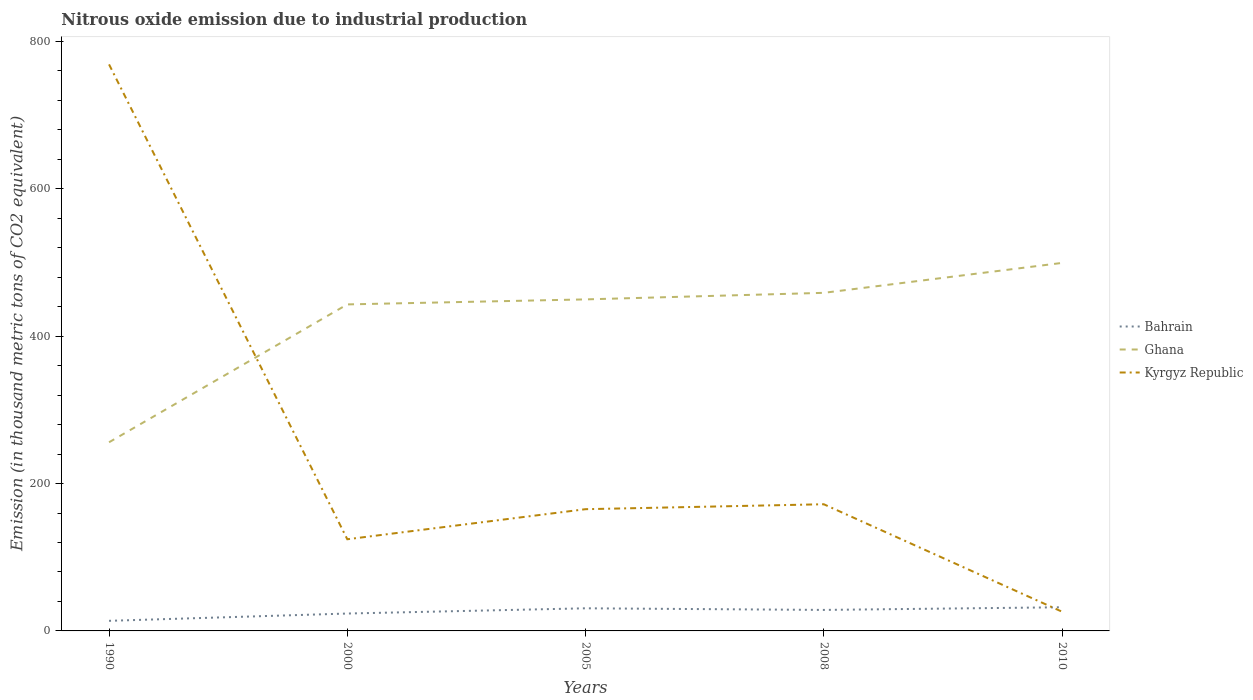How many different coloured lines are there?
Ensure brevity in your answer.  3. Across all years, what is the maximum amount of nitrous oxide emitted in Kyrgyz Republic?
Your answer should be very brief. 26.1. In which year was the amount of nitrous oxide emitted in Bahrain maximum?
Your answer should be compact. 1990. What is the total amount of nitrous oxide emitted in Kyrgyz Republic in the graph?
Your response must be concise. 742.7. What is the difference between the highest and the second highest amount of nitrous oxide emitted in Ghana?
Give a very brief answer. 243.4. How many lines are there?
Ensure brevity in your answer.  3. What is the difference between two consecutive major ticks on the Y-axis?
Your response must be concise. 200. Are the values on the major ticks of Y-axis written in scientific E-notation?
Give a very brief answer. No. Does the graph contain any zero values?
Your response must be concise. No. What is the title of the graph?
Ensure brevity in your answer.  Nitrous oxide emission due to industrial production. What is the label or title of the X-axis?
Make the answer very short. Years. What is the label or title of the Y-axis?
Make the answer very short. Emission (in thousand metric tons of CO2 equivalent). What is the Emission (in thousand metric tons of CO2 equivalent) of Ghana in 1990?
Provide a succinct answer. 256. What is the Emission (in thousand metric tons of CO2 equivalent) of Kyrgyz Republic in 1990?
Your answer should be very brief. 768.8. What is the Emission (in thousand metric tons of CO2 equivalent) of Bahrain in 2000?
Provide a short and direct response. 23.6. What is the Emission (in thousand metric tons of CO2 equivalent) of Ghana in 2000?
Ensure brevity in your answer.  443.1. What is the Emission (in thousand metric tons of CO2 equivalent) of Kyrgyz Republic in 2000?
Ensure brevity in your answer.  124.4. What is the Emission (in thousand metric tons of CO2 equivalent) of Bahrain in 2005?
Your answer should be very brief. 30.7. What is the Emission (in thousand metric tons of CO2 equivalent) in Ghana in 2005?
Offer a terse response. 449.9. What is the Emission (in thousand metric tons of CO2 equivalent) in Kyrgyz Republic in 2005?
Your response must be concise. 165.2. What is the Emission (in thousand metric tons of CO2 equivalent) of Ghana in 2008?
Make the answer very short. 458.8. What is the Emission (in thousand metric tons of CO2 equivalent) in Kyrgyz Republic in 2008?
Offer a very short reply. 171.9. What is the Emission (in thousand metric tons of CO2 equivalent) in Bahrain in 2010?
Give a very brief answer. 32.1. What is the Emission (in thousand metric tons of CO2 equivalent) in Ghana in 2010?
Provide a succinct answer. 499.4. What is the Emission (in thousand metric tons of CO2 equivalent) of Kyrgyz Republic in 2010?
Ensure brevity in your answer.  26.1. Across all years, what is the maximum Emission (in thousand metric tons of CO2 equivalent) in Bahrain?
Your answer should be compact. 32.1. Across all years, what is the maximum Emission (in thousand metric tons of CO2 equivalent) in Ghana?
Offer a terse response. 499.4. Across all years, what is the maximum Emission (in thousand metric tons of CO2 equivalent) in Kyrgyz Republic?
Your answer should be very brief. 768.8. Across all years, what is the minimum Emission (in thousand metric tons of CO2 equivalent) in Bahrain?
Your response must be concise. 13.7. Across all years, what is the minimum Emission (in thousand metric tons of CO2 equivalent) of Ghana?
Your answer should be compact. 256. Across all years, what is the minimum Emission (in thousand metric tons of CO2 equivalent) of Kyrgyz Republic?
Keep it short and to the point. 26.1. What is the total Emission (in thousand metric tons of CO2 equivalent) of Bahrain in the graph?
Give a very brief answer. 128.6. What is the total Emission (in thousand metric tons of CO2 equivalent) in Ghana in the graph?
Your answer should be very brief. 2107.2. What is the total Emission (in thousand metric tons of CO2 equivalent) of Kyrgyz Republic in the graph?
Provide a short and direct response. 1256.4. What is the difference between the Emission (in thousand metric tons of CO2 equivalent) in Bahrain in 1990 and that in 2000?
Make the answer very short. -9.9. What is the difference between the Emission (in thousand metric tons of CO2 equivalent) in Ghana in 1990 and that in 2000?
Your answer should be compact. -187.1. What is the difference between the Emission (in thousand metric tons of CO2 equivalent) of Kyrgyz Republic in 1990 and that in 2000?
Your answer should be compact. 644.4. What is the difference between the Emission (in thousand metric tons of CO2 equivalent) of Ghana in 1990 and that in 2005?
Your response must be concise. -193.9. What is the difference between the Emission (in thousand metric tons of CO2 equivalent) of Kyrgyz Republic in 1990 and that in 2005?
Offer a very short reply. 603.6. What is the difference between the Emission (in thousand metric tons of CO2 equivalent) of Bahrain in 1990 and that in 2008?
Make the answer very short. -14.8. What is the difference between the Emission (in thousand metric tons of CO2 equivalent) in Ghana in 1990 and that in 2008?
Your answer should be compact. -202.8. What is the difference between the Emission (in thousand metric tons of CO2 equivalent) of Kyrgyz Republic in 1990 and that in 2008?
Keep it short and to the point. 596.9. What is the difference between the Emission (in thousand metric tons of CO2 equivalent) of Bahrain in 1990 and that in 2010?
Your response must be concise. -18.4. What is the difference between the Emission (in thousand metric tons of CO2 equivalent) of Ghana in 1990 and that in 2010?
Keep it short and to the point. -243.4. What is the difference between the Emission (in thousand metric tons of CO2 equivalent) of Kyrgyz Republic in 1990 and that in 2010?
Make the answer very short. 742.7. What is the difference between the Emission (in thousand metric tons of CO2 equivalent) of Bahrain in 2000 and that in 2005?
Your answer should be very brief. -7.1. What is the difference between the Emission (in thousand metric tons of CO2 equivalent) in Ghana in 2000 and that in 2005?
Ensure brevity in your answer.  -6.8. What is the difference between the Emission (in thousand metric tons of CO2 equivalent) in Kyrgyz Republic in 2000 and that in 2005?
Offer a very short reply. -40.8. What is the difference between the Emission (in thousand metric tons of CO2 equivalent) of Bahrain in 2000 and that in 2008?
Give a very brief answer. -4.9. What is the difference between the Emission (in thousand metric tons of CO2 equivalent) in Ghana in 2000 and that in 2008?
Offer a very short reply. -15.7. What is the difference between the Emission (in thousand metric tons of CO2 equivalent) of Kyrgyz Republic in 2000 and that in 2008?
Offer a very short reply. -47.5. What is the difference between the Emission (in thousand metric tons of CO2 equivalent) in Bahrain in 2000 and that in 2010?
Offer a very short reply. -8.5. What is the difference between the Emission (in thousand metric tons of CO2 equivalent) in Ghana in 2000 and that in 2010?
Provide a short and direct response. -56.3. What is the difference between the Emission (in thousand metric tons of CO2 equivalent) of Kyrgyz Republic in 2000 and that in 2010?
Keep it short and to the point. 98.3. What is the difference between the Emission (in thousand metric tons of CO2 equivalent) of Bahrain in 2005 and that in 2008?
Ensure brevity in your answer.  2.2. What is the difference between the Emission (in thousand metric tons of CO2 equivalent) in Ghana in 2005 and that in 2008?
Make the answer very short. -8.9. What is the difference between the Emission (in thousand metric tons of CO2 equivalent) in Bahrain in 2005 and that in 2010?
Your response must be concise. -1.4. What is the difference between the Emission (in thousand metric tons of CO2 equivalent) in Ghana in 2005 and that in 2010?
Your response must be concise. -49.5. What is the difference between the Emission (in thousand metric tons of CO2 equivalent) of Kyrgyz Republic in 2005 and that in 2010?
Your answer should be compact. 139.1. What is the difference between the Emission (in thousand metric tons of CO2 equivalent) in Bahrain in 2008 and that in 2010?
Offer a very short reply. -3.6. What is the difference between the Emission (in thousand metric tons of CO2 equivalent) of Ghana in 2008 and that in 2010?
Your answer should be compact. -40.6. What is the difference between the Emission (in thousand metric tons of CO2 equivalent) of Kyrgyz Republic in 2008 and that in 2010?
Your answer should be very brief. 145.8. What is the difference between the Emission (in thousand metric tons of CO2 equivalent) in Bahrain in 1990 and the Emission (in thousand metric tons of CO2 equivalent) in Ghana in 2000?
Your answer should be very brief. -429.4. What is the difference between the Emission (in thousand metric tons of CO2 equivalent) in Bahrain in 1990 and the Emission (in thousand metric tons of CO2 equivalent) in Kyrgyz Republic in 2000?
Provide a short and direct response. -110.7. What is the difference between the Emission (in thousand metric tons of CO2 equivalent) in Ghana in 1990 and the Emission (in thousand metric tons of CO2 equivalent) in Kyrgyz Republic in 2000?
Your answer should be very brief. 131.6. What is the difference between the Emission (in thousand metric tons of CO2 equivalent) in Bahrain in 1990 and the Emission (in thousand metric tons of CO2 equivalent) in Ghana in 2005?
Your answer should be very brief. -436.2. What is the difference between the Emission (in thousand metric tons of CO2 equivalent) of Bahrain in 1990 and the Emission (in thousand metric tons of CO2 equivalent) of Kyrgyz Republic in 2005?
Your answer should be compact. -151.5. What is the difference between the Emission (in thousand metric tons of CO2 equivalent) of Ghana in 1990 and the Emission (in thousand metric tons of CO2 equivalent) of Kyrgyz Republic in 2005?
Provide a short and direct response. 90.8. What is the difference between the Emission (in thousand metric tons of CO2 equivalent) in Bahrain in 1990 and the Emission (in thousand metric tons of CO2 equivalent) in Ghana in 2008?
Provide a short and direct response. -445.1. What is the difference between the Emission (in thousand metric tons of CO2 equivalent) in Bahrain in 1990 and the Emission (in thousand metric tons of CO2 equivalent) in Kyrgyz Republic in 2008?
Give a very brief answer. -158.2. What is the difference between the Emission (in thousand metric tons of CO2 equivalent) of Ghana in 1990 and the Emission (in thousand metric tons of CO2 equivalent) of Kyrgyz Republic in 2008?
Your answer should be very brief. 84.1. What is the difference between the Emission (in thousand metric tons of CO2 equivalent) of Bahrain in 1990 and the Emission (in thousand metric tons of CO2 equivalent) of Ghana in 2010?
Offer a terse response. -485.7. What is the difference between the Emission (in thousand metric tons of CO2 equivalent) in Ghana in 1990 and the Emission (in thousand metric tons of CO2 equivalent) in Kyrgyz Republic in 2010?
Your answer should be very brief. 229.9. What is the difference between the Emission (in thousand metric tons of CO2 equivalent) of Bahrain in 2000 and the Emission (in thousand metric tons of CO2 equivalent) of Ghana in 2005?
Provide a succinct answer. -426.3. What is the difference between the Emission (in thousand metric tons of CO2 equivalent) in Bahrain in 2000 and the Emission (in thousand metric tons of CO2 equivalent) in Kyrgyz Republic in 2005?
Ensure brevity in your answer.  -141.6. What is the difference between the Emission (in thousand metric tons of CO2 equivalent) in Ghana in 2000 and the Emission (in thousand metric tons of CO2 equivalent) in Kyrgyz Republic in 2005?
Ensure brevity in your answer.  277.9. What is the difference between the Emission (in thousand metric tons of CO2 equivalent) of Bahrain in 2000 and the Emission (in thousand metric tons of CO2 equivalent) of Ghana in 2008?
Offer a very short reply. -435.2. What is the difference between the Emission (in thousand metric tons of CO2 equivalent) of Bahrain in 2000 and the Emission (in thousand metric tons of CO2 equivalent) of Kyrgyz Republic in 2008?
Keep it short and to the point. -148.3. What is the difference between the Emission (in thousand metric tons of CO2 equivalent) of Ghana in 2000 and the Emission (in thousand metric tons of CO2 equivalent) of Kyrgyz Republic in 2008?
Your response must be concise. 271.2. What is the difference between the Emission (in thousand metric tons of CO2 equivalent) of Bahrain in 2000 and the Emission (in thousand metric tons of CO2 equivalent) of Ghana in 2010?
Give a very brief answer. -475.8. What is the difference between the Emission (in thousand metric tons of CO2 equivalent) in Ghana in 2000 and the Emission (in thousand metric tons of CO2 equivalent) in Kyrgyz Republic in 2010?
Keep it short and to the point. 417. What is the difference between the Emission (in thousand metric tons of CO2 equivalent) in Bahrain in 2005 and the Emission (in thousand metric tons of CO2 equivalent) in Ghana in 2008?
Make the answer very short. -428.1. What is the difference between the Emission (in thousand metric tons of CO2 equivalent) in Bahrain in 2005 and the Emission (in thousand metric tons of CO2 equivalent) in Kyrgyz Republic in 2008?
Your response must be concise. -141.2. What is the difference between the Emission (in thousand metric tons of CO2 equivalent) of Ghana in 2005 and the Emission (in thousand metric tons of CO2 equivalent) of Kyrgyz Republic in 2008?
Your answer should be very brief. 278. What is the difference between the Emission (in thousand metric tons of CO2 equivalent) of Bahrain in 2005 and the Emission (in thousand metric tons of CO2 equivalent) of Ghana in 2010?
Offer a very short reply. -468.7. What is the difference between the Emission (in thousand metric tons of CO2 equivalent) in Bahrain in 2005 and the Emission (in thousand metric tons of CO2 equivalent) in Kyrgyz Republic in 2010?
Offer a very short reply. 4.6. What is the difference between the Emission (in thousand metric tons of CO2 equivalent) in Ghana in 2005 and the Emission (in thousand metric tons of CO2 equivalent) in Kyrgyz Republic in 2010?
Your answer should be compact. 423.8. What is the difference between the Emission (in thousand metric tons of CO2 equivalent) of Bahrain in 2008 and the Emission (in thousand metric tons of CO2 equivalent) of Ghana in 2010?
Ensure brevity in your answer.  -470.9. What is the difference between the Emission (in thousand metric tons of CO2 equivalent) of Bahrain in 2008 and the Emission (in thousand metric tons of CO2 equivalent) of Kyrgyz Republic in 2010?
Ensure brevity in your answer.  2.4. What is the difference between the Emission (in thousand metric tons of CO2 equivalent) in Ghana in 2008 and the Emission (in thousand metric tons of CO2 equivalent) in Kyrgyz Republic in 2010?
Your response must be concise. 432.7. What is the average Emission (in thousand metric tons of CO2 equivalent) of Bahrain per year?
Provide a succinct answer. 25.72. What is the average Emission (in thousand metric tons of CO2 equivalent) in Ghana per year?
Give a very brief answer. 421.44. What is the average Emission (in thousand metric tons of CO2 equivalent) of Kyrgyz Republic per year?
Your answer should be very brief. 251.28. In the year 1990, what is the difference between the Emission (in thousand metric tons of CO2 equivalent) in Bahrain and Emission (in thousand metric tons of CO2 equivalent) in Ghana?
Make the answer very short. -242.3. In the year 1990, what is the difference between the Emission (in thousand metric tons of CO2 equivalent) of Bahrain and Emission (in thousand metric tons of CO2 equivalent) of Kyrgyz Republic?
Your response must be concise. -755.1. In the year 1990, what is the difference between the Emission (in thousand metric tons of CO2 equivalent) in Ghana and Emission (in thousand metric tons of CO2 equivalent) in Kyrgyz Republic?
Provide a succinct answer. -512.8. In the year 2000, what is the difference between the Emission (in thousand metric tons of CO2 equivalent) in Bahrain and Emission (in thousand metric tons of CO2 equivalent) in Ghana?
Your response must be concise. -419.5. In the year 2000, what is the difference between the Emission (in thousand metric tons of CO2 equivalent) in Bahrain and Emission (in thousand metric tons of CO2 equivalent) in Kyrgyz Republic?
Give a very brief answer. -100.8. In the year 2000, what is the difference between the Emission (in thousand metric tons of CO2 equivalent) of Ghana and Emission (in thousand metric tons of CO2 equivalent) of Kyrgyz Republic?
Keep it short and to the point. 318.7. In the year 2005, what is the difference between the Emission (in thousand metric tons of CO2 equivalent) in Bahrain and Emission (in thousand metric tons of CO2 equivalent) in Ghana?
Provide a succinct answer. -419.2. In the year 2005, what is the difference between the Emission (in thousand metric tons of CO2 equivalent) in Bahrain and Emission (in thousand metric tons of CO2 equivalent) in Kyrgyz Republic?
Your answer should be compact. -134.5. In the year 2005, what is the difference between the Emission (in thousand metric tons of CO2 equivalent) in Ghana and Emission (in thousand metric tons of CO2 equivalent) in Kyrgyz Republic?
Make the answer very short. 284.7. In the year 2008, what is the difference between the Emission (in thousand metric tons of CO2 equivalent) of Bahrain and Emission (in thousand metric tons of CO2 equivalent) of Ghana?
Offer a terse response. -430.3. In the year 2008, what is the difference between the Emission (in thousand metric tons of CO2 equivalent) of Bahrain and Emission (in thousand metric tons of CO2 equivalent) of Kyrgyz Republic?
Your answer should be compact. -143.4. In the year 2008, what is the difference between the Emission (in thousand metric tons of CO2 equivalent) of Ghana and Emission (in thousand metric tons of CO2 equivalent) of Kyrgyz Republic?
Make the answer very short. 286.9. In the year 2010, what is the difference between the Emission (in thousand metric tons of CO2 equivalent) in Bahrain and Emission (in thousand metric tons of CO2 equivalent) in Ghana?
Your answer should be compact. -467.3. In the year 2010, what is the difference between the Emission (in thousand metric tons of CO2 equivalent) of Bahrain and Emission (in thousand metric tons of CO2 equivalent) of Kyrgyz Republic?
Your answer should be very brief. 6. In the year 2010, what is the difference between the Emission (in thousand metric tons of CO2 equivalent) in Ghana and Emission (in thousand metric tons of CO2 equivalent) in Kyrgyz Republic?
Make the answer very short. 473.3. What is the ratio of the Emission (in thousand metric tons of CO2 equivalent) in Bahrain in 1990 to that in 2000?
Ensure brevity in your answer.  0.58. What is the ratio of the Emission (in thousand metric tons of CO2 equivalent) in Ghana in 1990 to that in 2000?
Keep it short and to the point. 0.58. What is the ratio of the Emission (in thousand metric tons of CO2 equivalent) of Kyrgyz Republic in 1990 to that in 2000?
Keep it short and to the point. 6.18. What is the ratio of the Emission (in thousand metric tons of CO2 equivalent) in Bahrain in 1990 to that in 2005?
Offer a very short reply. 0.45. What is the ratio of the Emission (in thousand metric tons of CO2 equivalent) in Ghana in 1990 to that in 2005?
Offer a terse response. 0.57. What is the ratio of the Emission (in thousand metric tons of CO2 equivalent) of Kyrgyz Republic in 1990 to that in 2005?
Offer a very short reply. 4.65. What is the ratio of the Emission (in thousand metric tons of CO2 equivalent) of Bahrain in 1990 to that in 2008?
Your response must be concise. 0.48. What is the ratio of the Emission (in thousand metric tons of CO2 equivalent) of Ghana in 1990 to that in 2008?
Keep it short and to the point. 0.56. What is the ratio of the Emission (in thousand metric tons of CO2 equivalent) of Kyrgyz Republic in 1990 to that in 2008?
Provide a short and direct response. 4.47. What is the ratio of the Emission (in thousand metric tons of CO2 equivalent) in Bahrain in 1990 to that in 2010?
Offer a terse response. 0.43. What is the ratio of the Emission (in thousand metric tons of CO2 equivalent) in Ghana in 1990 to that in 2010?
Provide a succinct answer. 0.51. What is the ratio of the Emission (in thousand metric tons of CO2 equivalent) of Kyrgyz Republic in 1990 to that in 2010?
Provide a succinct answer. 29.46. What is the ratio of the Emission (in thousand metric tons of CO2 equivalent) of Bahrain in 2000 to that in 2005?
Make the answer very short. 0.77. What is the ratio of the Emission (in thousand metric tons of CO2 equivalent) in Ghana in 2000 to that in 2005?
Keep it short and to the point. 0.98. What is the ratio of the Emission (in thousand metric tons of CO2 equivalent) in Kyrgyz Republic in 2000 to that in 2005?
Provide a succinct answer. 0.75. What is the ratio of the Emission (in thousand metric tons of CO2 equivalent) of Bahrain in 2000 to that in 2008?
Your answer should be compact. 0.83. What is the ratio of the Emission (in thousand metric tons of CO2 equivalent) in Ghana in 2000 to that in 2008?
Your answer should be very brief. 0.97. What is the ratio of the Emission (in thousand metric tons of CO2 equivalent) of Kyrgyz Republic in 2000 to that in 2008?
Give a very brief answer. 0.72. What is the ratio of the Emission (in thousand metric tons of CO2 equivalent) of Bahrain in 2000 to that in 2010?
Offer a terse response. 0.74. What is the ratio of the Emission (in thousand metric tons of CO2 equivalent) of Ghana in 2000 to that in 2010?
Provide a succinct answer. 0.89. What is the ratio of the Emission (in thousand metric tons of CO2 equivalent) in Kyrgyz Republic in 2000 to that in 2010?
Make the answer very short. 4.77. What is the ratio of the Emission (in thousand metric tons of CO2 equivalent) of Bahrain in 2005 to that in 2008?
Your answer should be compact. 1.08. What is the ratio of the Emission (in thousand metric tons of CO2 equivalent) of Ghana in 2005 to that in 2008?
Your answer should be very brief. 0.98. What is the ratio of the Emission (in thousand metric tons of CO2 equivalent) in Kyrgyz Republic in 2005 to that in 2008?
Your answer should be very brief. 0.96. What is the ratio of the Emission (in thousand metric tons of CO2 equivalent) in Bahrain in 2005 to that in 2010?
Keep it short and to the point. 0.96. What is the ratio of the Emission (in thousand metric tons of CO2 equivalent) of Ghana in 2005 to that in 2010?
Your response must be concise. 0.9. What is the ratio of the Emission (in thousand metric tons of CO2 equivalent) in Kyrgyz Republic in 2005 to that in 2010?
Make the answer very short. 6.33. What is the ratio of the Emission (in thousand metric tons of CO2 equivalent) in Bahrain in 2008 to that in 2010?
Make the answer very short. 0.89. What is the ratio of the Emission (in thousand metric tons of CO2 equivalent) in Ghana in 2008 to that in 2010?
Ensure brevity in your answer.  0.92. What is the ratio of the Emission (in thousand metric tons of CO2 equivalent) of Kyrgyz Republic in 2008 to that in 2010?
Offer a very short reply. 6.59. What is the difference between the highest and the second highest Emission (in thousand metric tons of CO2 equivalent) of Bahrain?
Make the answer very short. 1.4. What is the difference between the highest and the second highest Emission (in thousand metric tons of CO2 equivalent) of Ghana?
Give a very brief answer. 40.6. What is the difference between the highest and the second highest Emission (in thousand metric tons of CO2 equivalent) in Kyrgyz Republic?
Give a very brief answer. 596.9. What is the difference between the highest and the lowest Emission (in thousand metric tons of CO2 equivalent) of Ghana?
Provide a succinct answer. 243.4. What is the difference between the highest and the lowest Emission (in thousand metric tons of CO2 equivalent) in Kyrgyz Republic?
Provide a succinct answer. 742.7. 